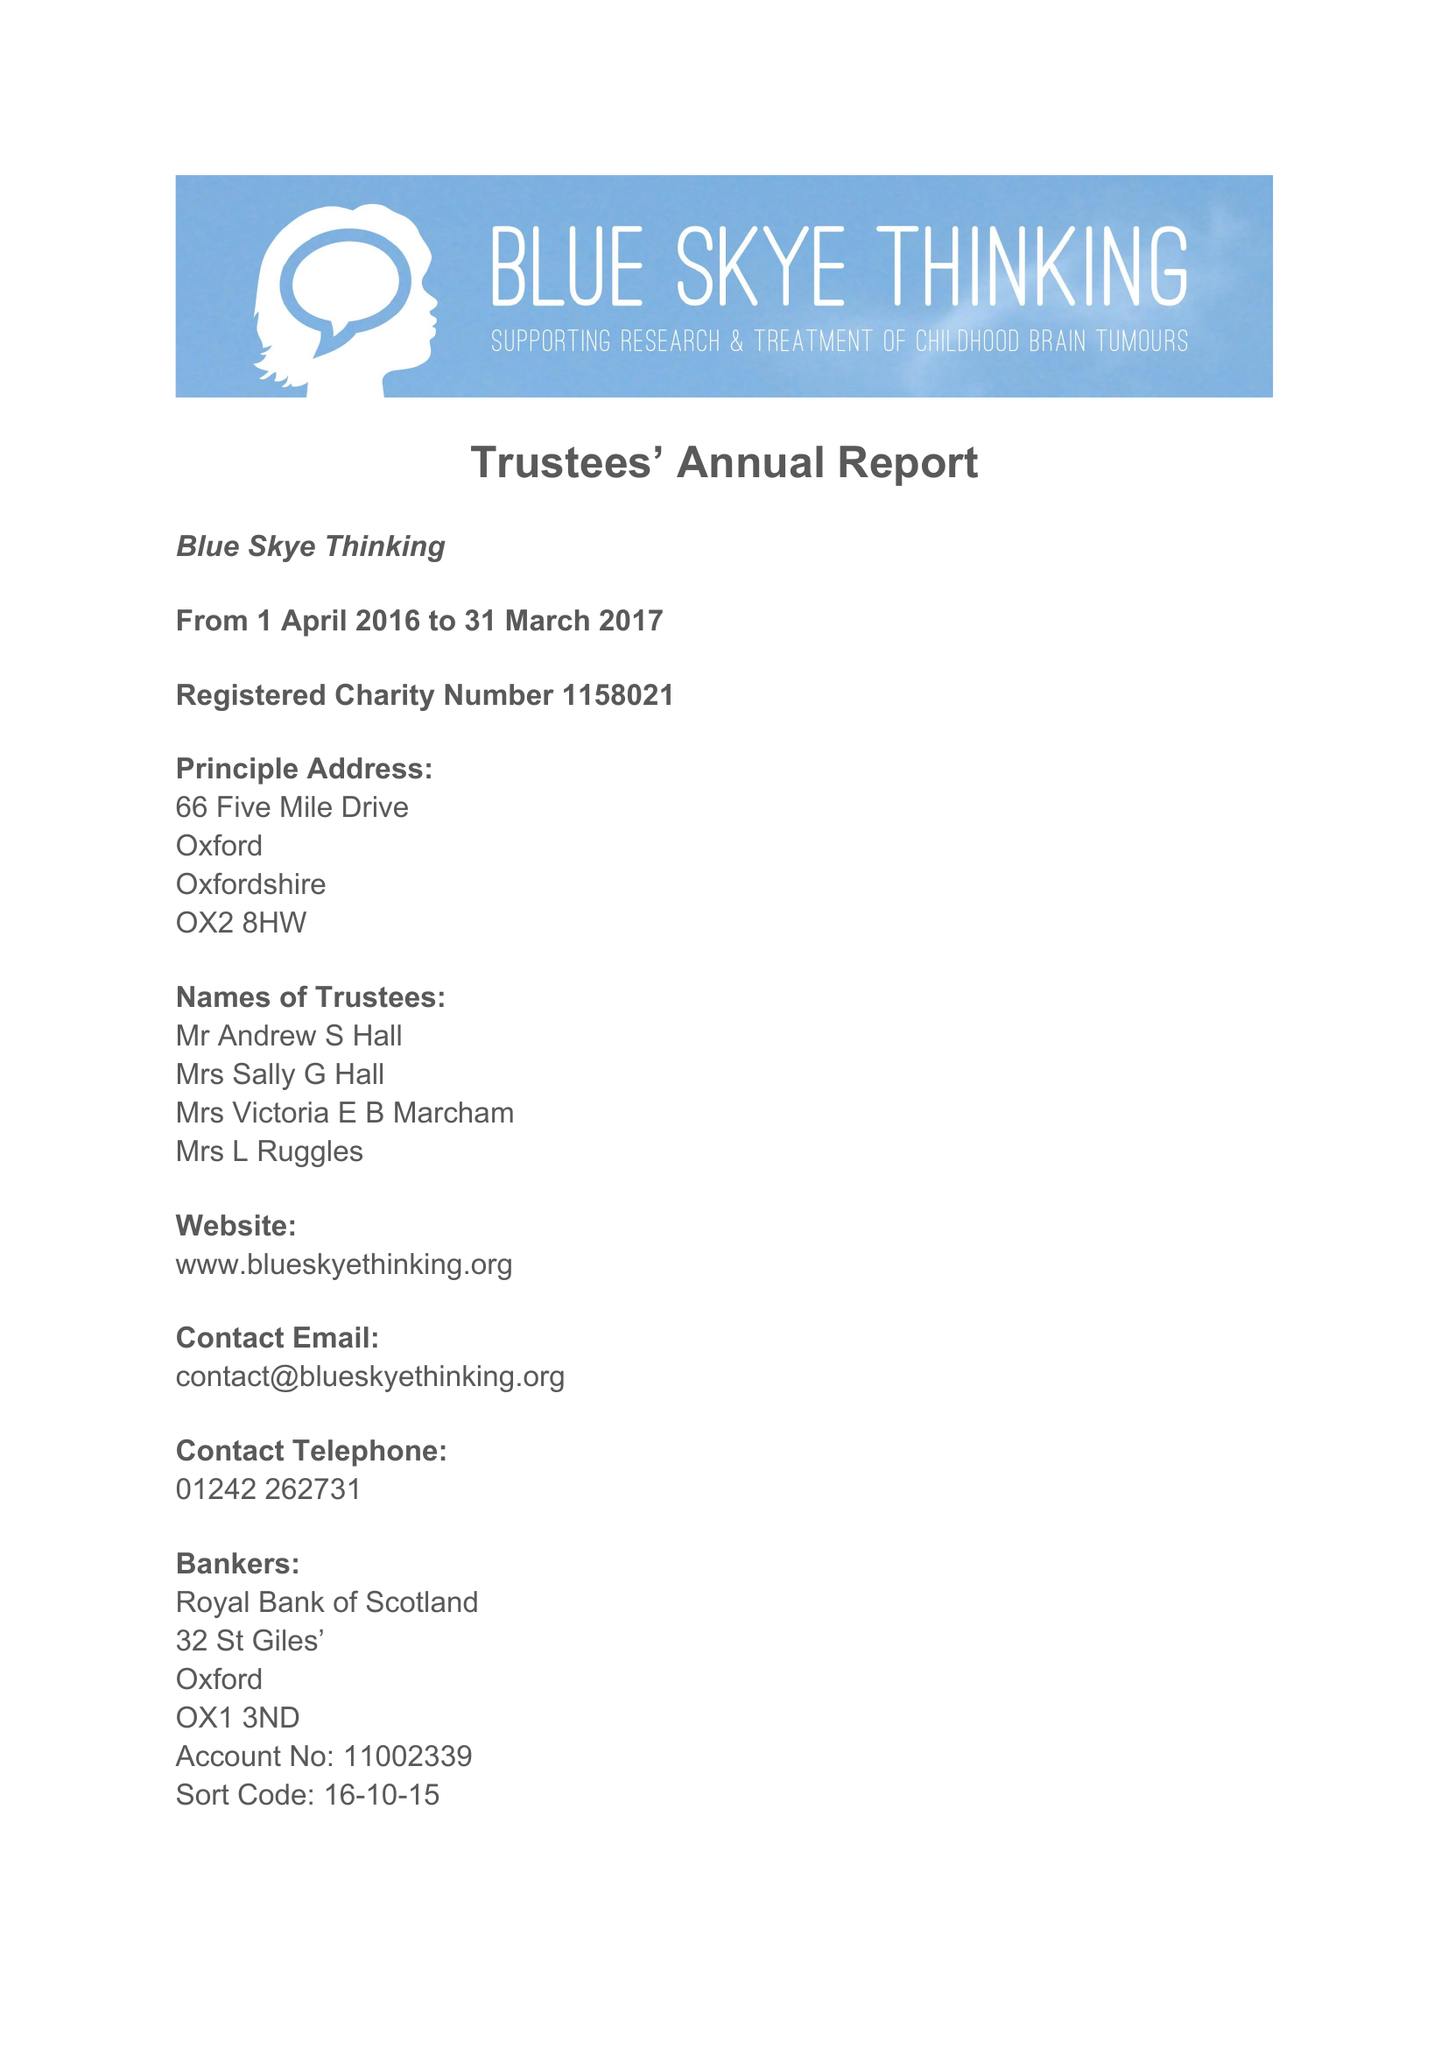What is the value for the address__postcode?
Answer the question using a single word or phrase. OX2 8HW 